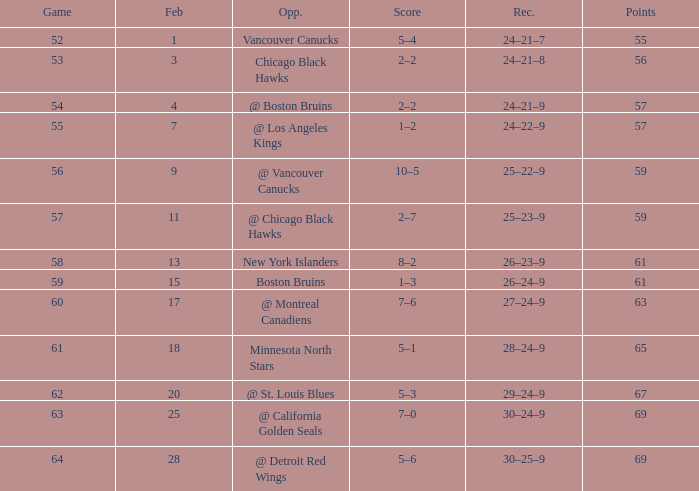Which opponent has a game larger than 61, february smaller than 28, and fewer points than 69? @ St. Louis Blues. 